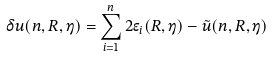<formula> <loc_0><loc_0><loc_500><loc_500>\delta u ( n , R , \eta ) = \sum _ { i = 1 } ^ { n } 2 \epsilon _ { i } ( R , \eta ) - \tilde { u } ( n , R , \eta )</formula> 